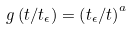Convert formula to latex. <formula><loc_0><loc_0><loc_500><loc_500>g \left ( t / t _ { \epsilon } \right ) = \left ( t _ { \epsilon } / t \right ) ^ { a }</formula> 